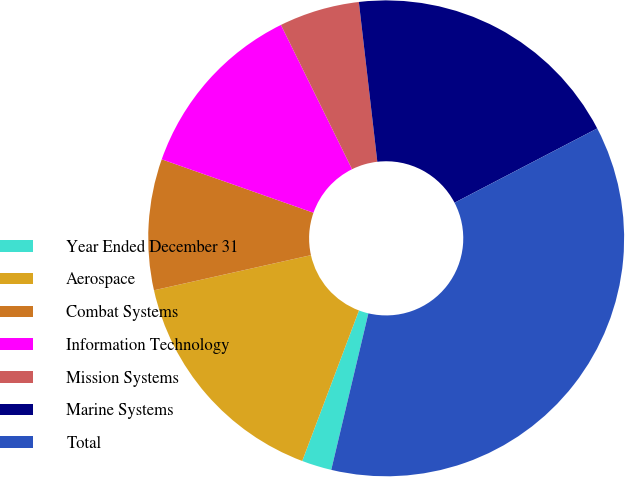Convert chart to OTSL. <chart><loc_0><loc_0><loc_500><loc_500><pie_chart><fcel>Year Ended December 31<fcel>Aerospace<fcel>Combat Systems<fcel>Information Technology<fcel>Mission Systems<fcel>Marine Systems<fcel>Total<nl><fcel>2.03%<fcel>15.76%<fcel>8.89%<fcel>12.32%<fcel>5.46%<fcel>19.19%<fcel>36.35%<nl></chart> 